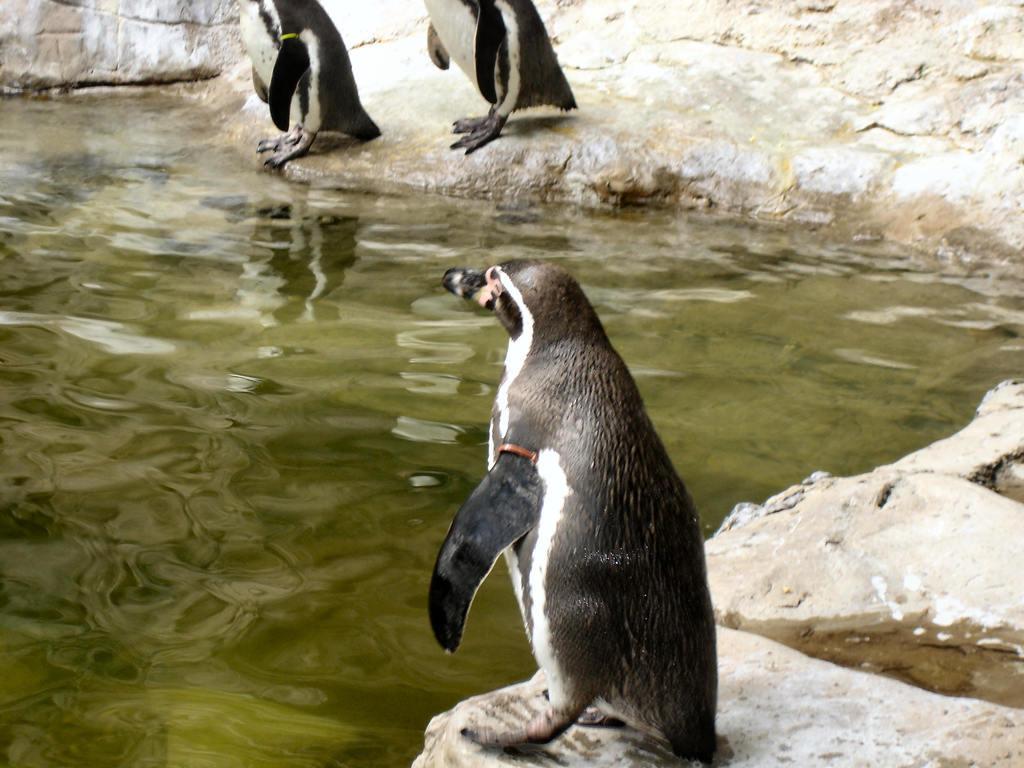Can you describe this image briefly? In this picture we can see three penguins are present on the rocks. In the background of the image we can see the water. 